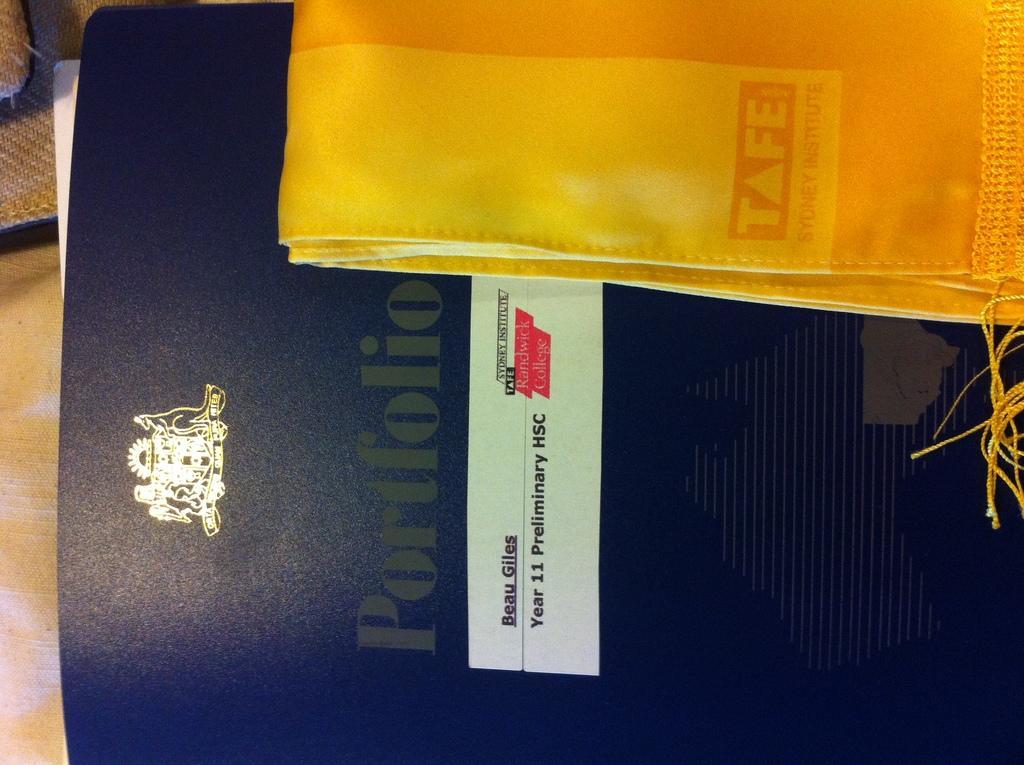Describe this image in one or two sentences. In this image we can see the cover of a file, on the file there is a cloth. 